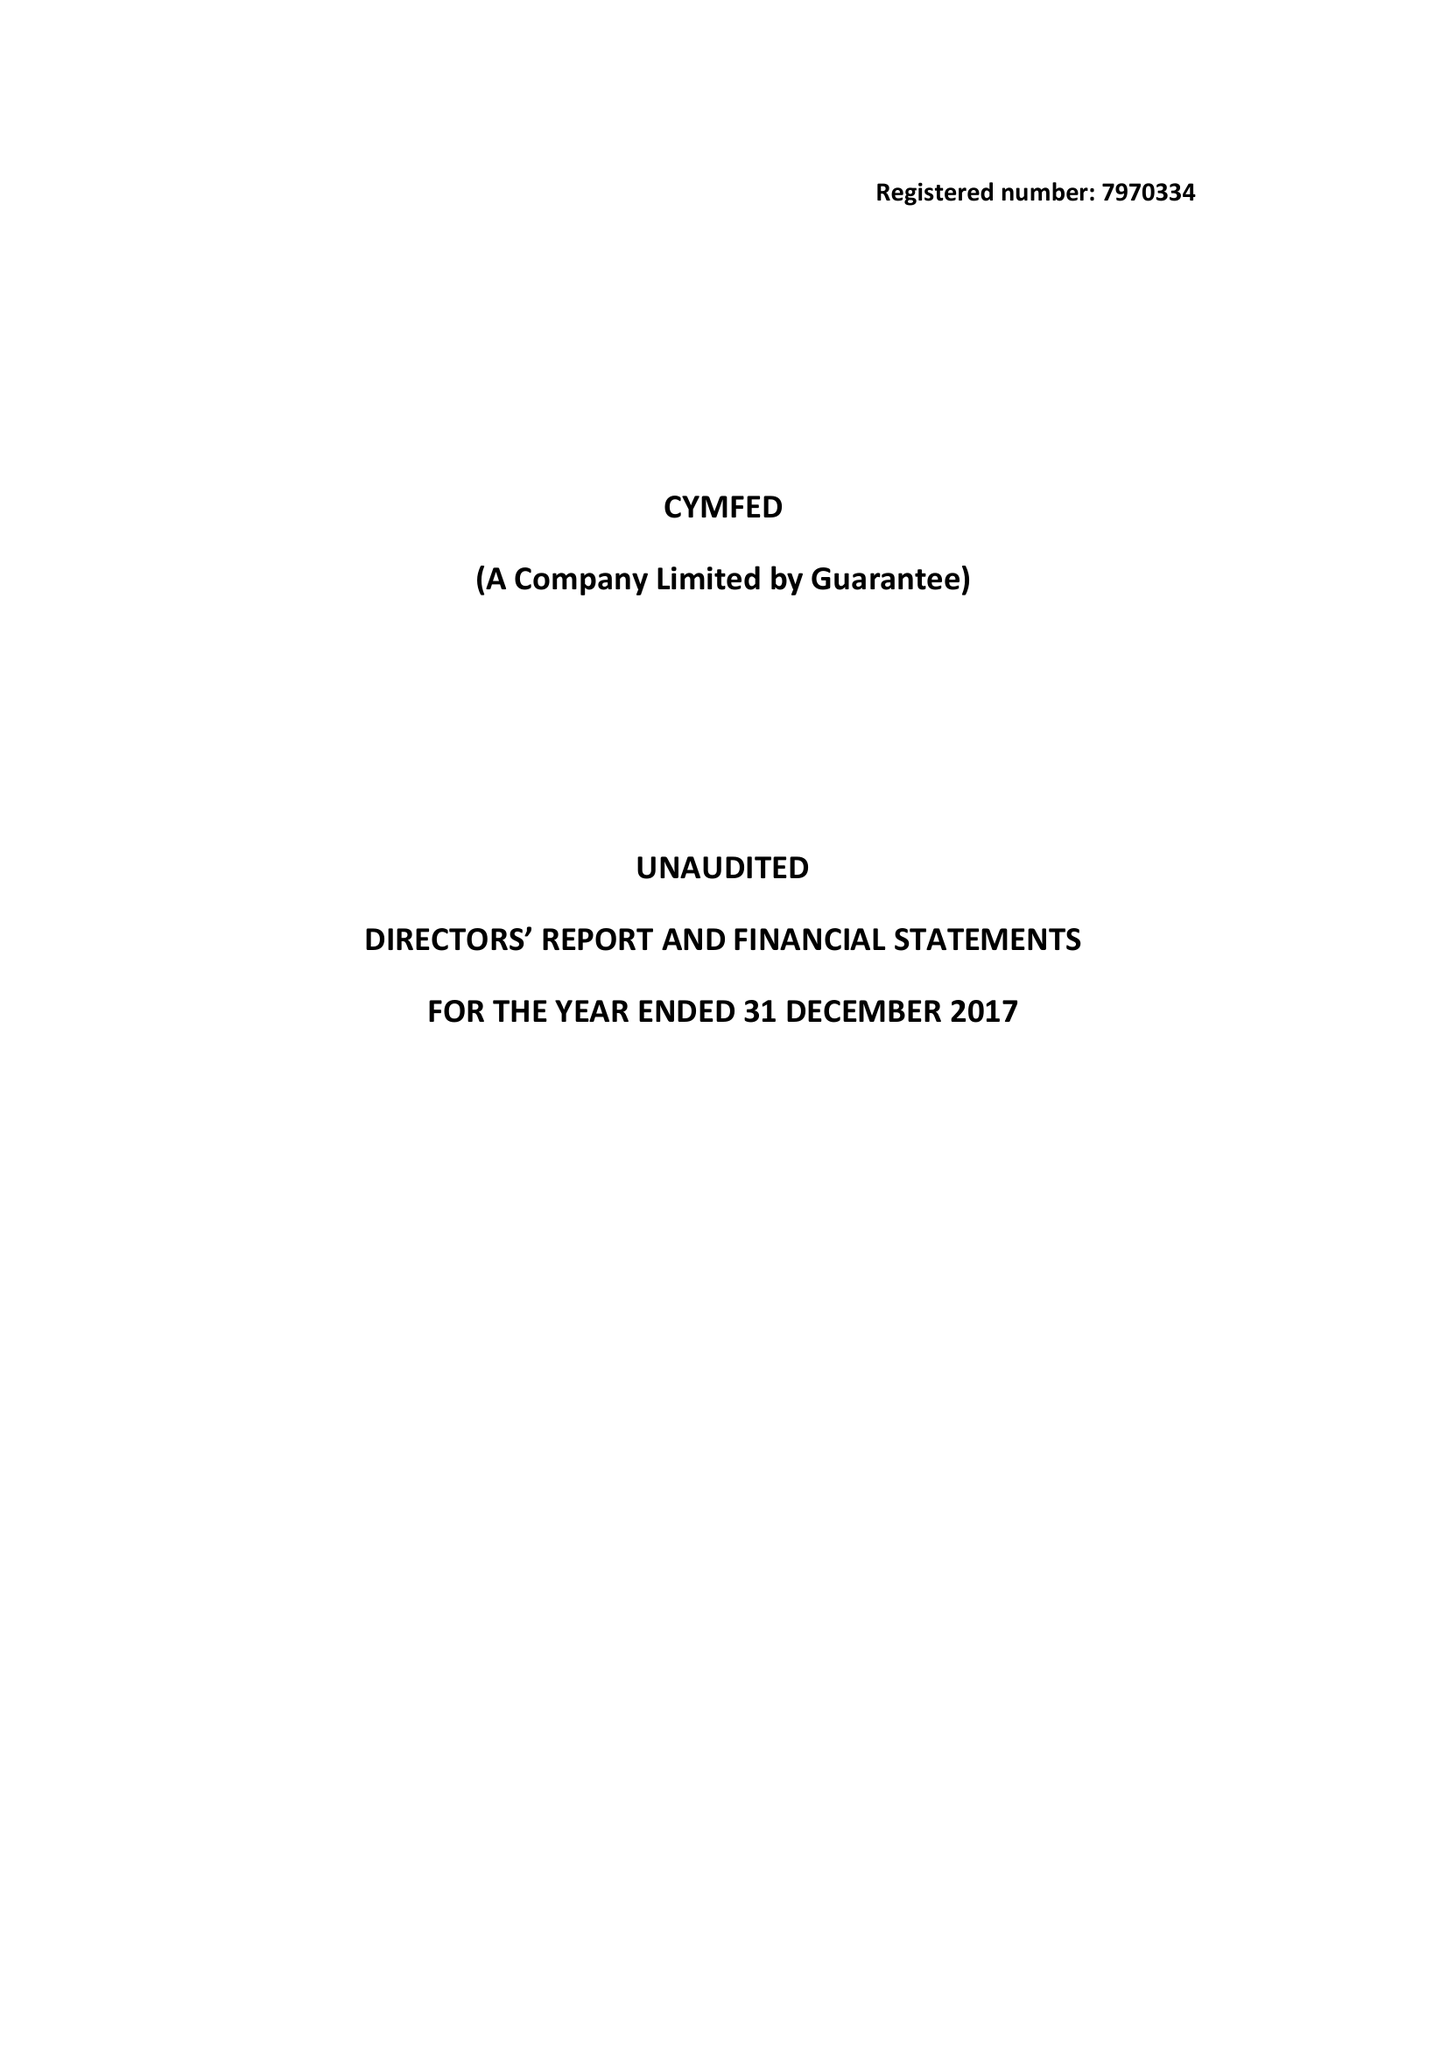What is the value for the spending_annually_in_british_pounds?
Answer the question using a single word or phrase. 185092.00 